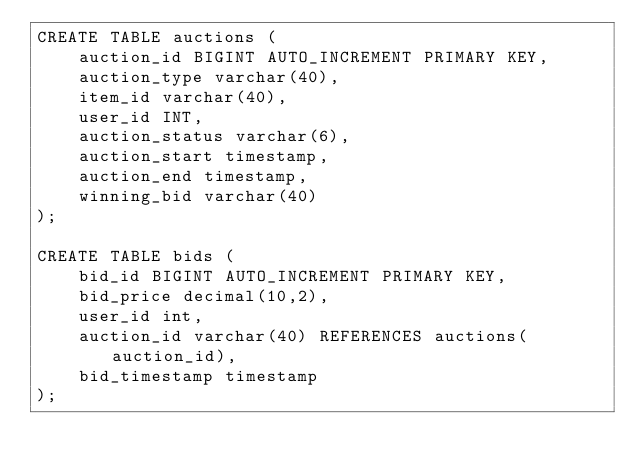<code> <loc_0><loc_0><loc_500><loc_500><_SQL_>CREATE TABLE auctions (
    auction_id BIGINT AUTO_INCREMENT PRIMARY KEY,
    auction_type varchar(40),
    item_id varchar(40),
    user_id INT,
    auction_status varchar(6),
    auction_start timestamp,
    auction_end timestamp,
    winning_bid varchar(40)
);

CREATE TABLE bids (
    bid_id BIGINT AUTO_INCREMENT PRIMARY KEY,
    bid_price decimal(10,2),
    user_id int,
    auction_id varchar(40) REFERENCES auctions(auction_id),
    bid_timestamp timestamp
);
</code> 